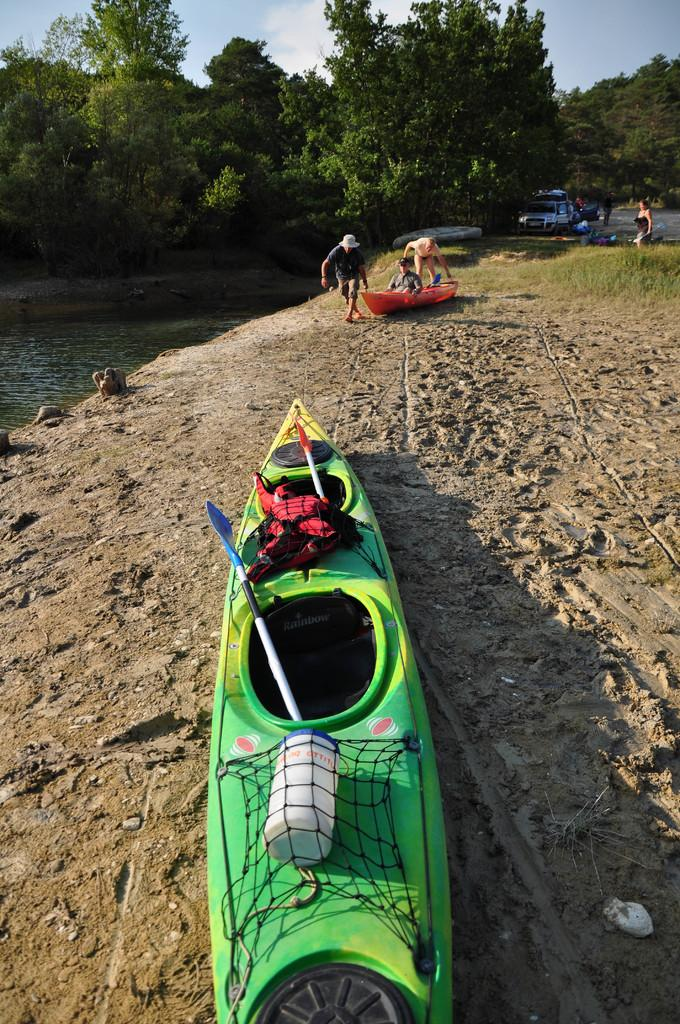What is the main object on the ground in the image? There is a boat on the ground in the image. What can be seen in the background of the image? There are trees, water, people, and grass visible in the background of the image. What is the condition of the sky in the image? The sky in the image has clouds. What type of feather can be seen on the boat in the image? There is no feather present on the boat in the image. What driving skills do the people in the background of the image possess? There is no indication of driving or any vehicles in the image, so it cannot be determined what driving skills the people might possess. 